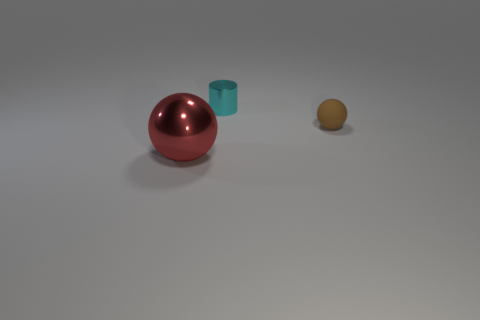There is a metal thing in front of the cyan metallic object; is it the same size as the brown ball?
Offer a terse response. No. How big is the red shiny object?
Your answer should be compact. Large. What color is the metal thing that is behind the metal thing left of the metallic object that is behind the big thing?
Your answer should be compact. Cyan. How many objects are behind the matte ball and left of the cyan metallic object?
Your answer should be very brief. 0. There is a metallic thing that is the same shape as the rubber object; what is its size?
Offer a very short reply. Large. How many spheres are behind the metallic thing that is in front of the metal object that is behind the large metal sphere?
Keep it short and to the point. 1. The tiny cylinder that is left of the ball to the right of the small cyan cylinder is what color?
Keep it short and to the point. Cyan. What number of other objects are the same material as the brown object?
Your answer should be compact. 0. There is a shiny thing behind the matte ball; what number of things are behind it?
Your response must be concise. 0. Are there any other things that have the same shape as the small matte object?
Provide a succinct answer. Yes. 